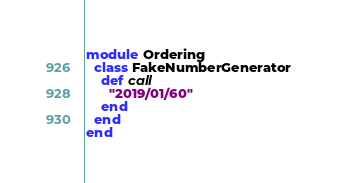<code> <loc_0><loc_0><loc_500><loc_500><_Ruby_>module Ordering
  class FakeNumberGenerator
    def call
      "2019/01/60"
    end
  end
end</code> 